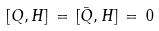<formula> <loc_0><loc_0><loc_500><loc_500>[ Q , H ] \, = \, [ \bar { Q } , H ] \, = \, 0</formula> 